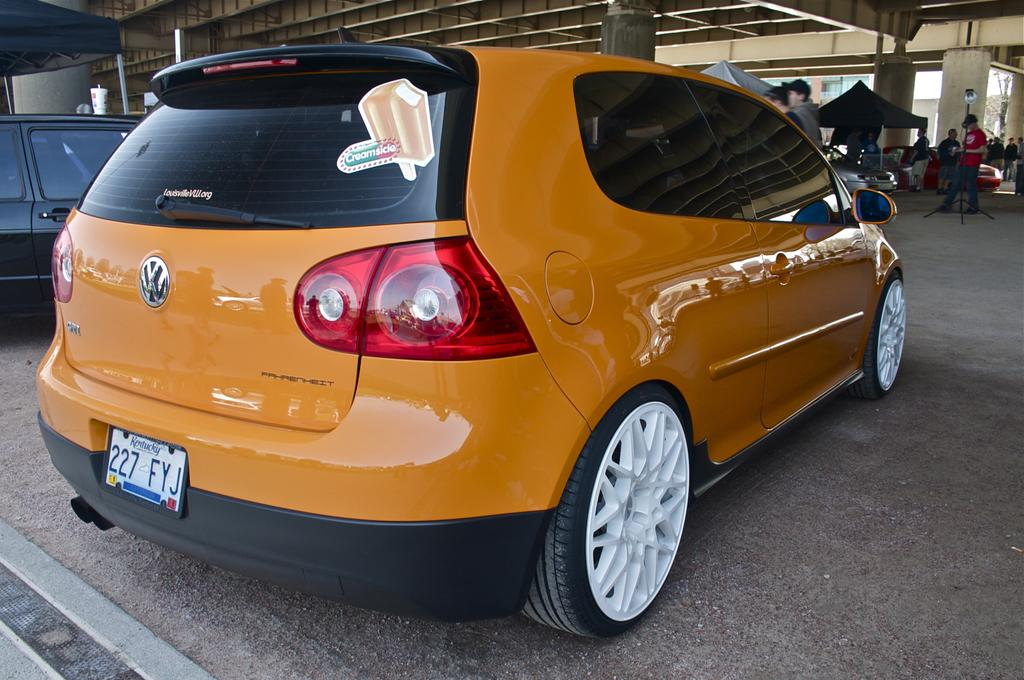What can be seen in the image that is used for transportation? There are cars parked in the image. What are the people in front of the cars doing? There are people standing in front of the cars. What else can be seen in the image besides cars and people? There are objects and pillars in the image. What is visible at the top of the image? The ceiling is visible at the top of the image. Where is the oven located in the image? There is no oven present in the image. What type of wrench can be seen being used by the people in the image? There is no wrench visible in the image; the people are simply standing in front of the cars. 